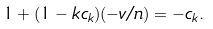Convert formula to latex. <formula><loc_0><loc_0><loc_500><loc_500>1 + ( 1 - k c _ { k } ) ( - v / n ) = - c _ { k } .</formula> 